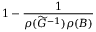<formula> <loc_0><loc_0><loc_500><loc_500>1 - \frac { 1 } { \rho ( \widetilde { G } ^ { - 1 } ) \rho ( B ) }</formula> 